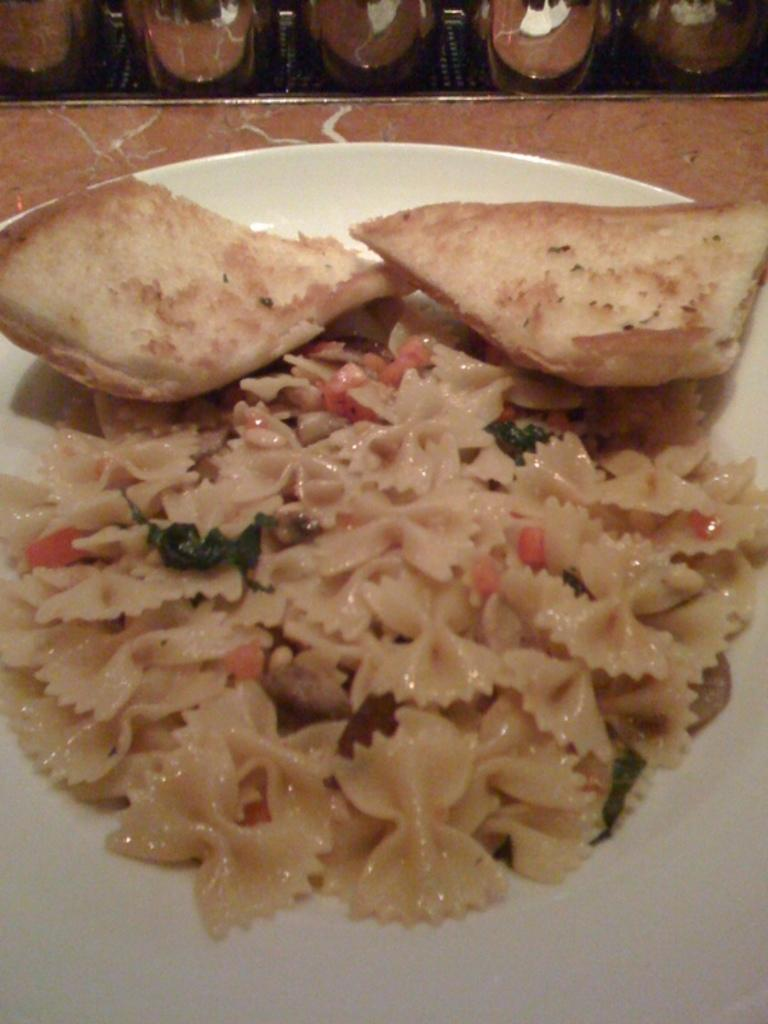What object is present on the plate in the image? There is a food item on the plate. What is the color of the plate? The plate is white in color. What type of food can be seen on the plate? There are pieces of bread on the plate. What type of rock can be seen supporting the plate in the image? There is no rock present in the image; the plate is likely resting on a table or other surface. 